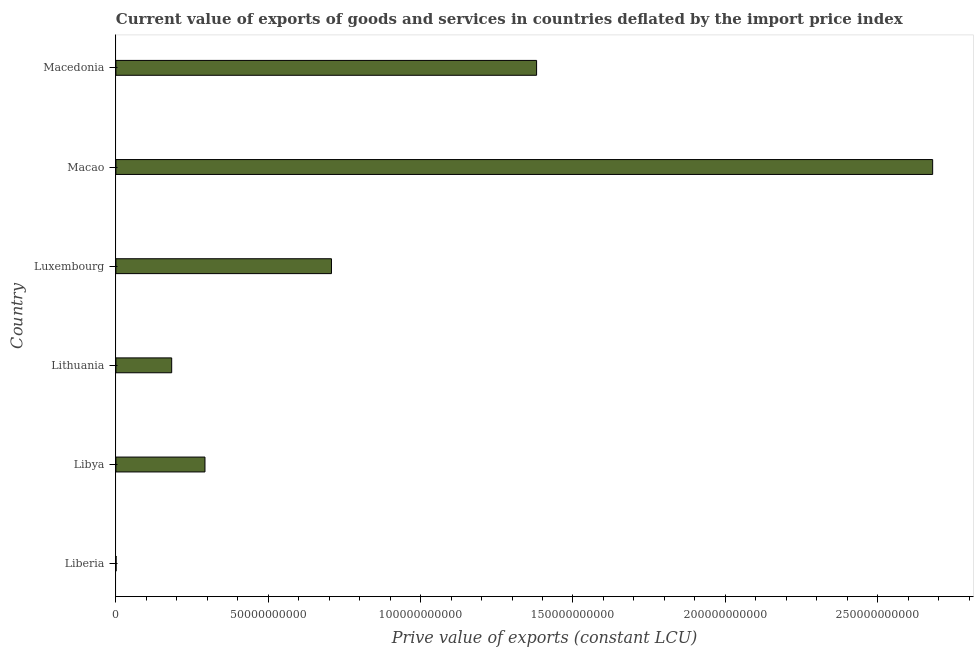Does the graph contain any zero values?
Offer a terse response. No. What is the title of the graph?
Your response must be concise. Current value of exports of goods and services in countries deflated by the import price index. What is the label or title of the X-axis?
Make the answer very short. Prive value of exports (constant LCU). What is the price value of exports in Lithuania?
Your answer should be very brief. 1.83e+1. Across all countries, what is the maximum price value of exports?
Give a very brief answer. 2.68e+11. Across all countries, what is the minimum price value of exports?
Offer a very short reply. 5.83e+07. In which country was the price value of exports maximum?
Your answer should be compact. Macao. In which country was the price value of exports minimum?
Your response must be concise. Liberia. What is the sum of the price value of exports?
Your answer should be very brief. 5.24e+11. What is the difference between the price value of exports in Libya and Macedonia?
Keep it short and to the point. -1.09e+11. What is the average price value of exports per country?
Ensure brevity in your answer.  8.74e+1. What is the median price value of exports?
Offer a very short reply. 5.00e+1. In how many countries, is the price value of exports greater than 170000000000 LCU?
Provide a short and direct response. 1. What is the ratio of the price value of exports in Libya to that in Macedonia?
Keep it short and to the point. 0.21. Is the price value of exports in Liberia less than that in Macao?
Your response must be concise. Yes. What is the difference between the highest and the second highest price value of exports?
Your answer should be very brief. 1.30e+11. What is the difference between the highest and the lowest price value of exports?
Provide a succinct answer. 2.68e+11. Are the values on the major ticks of X-axis written in scientific E-notation?
Your response must be concise. No. What is the Prive value of exports (constant LCU) in Liberia?
Ensure brevity in your answer.  5.83e+07. What is the Prive value of exports (constant LCU) in Libya?
Your answer should be very brief. 2.92e+1. What is the Prive value of exports (constant LCU) of Lithuania?
Keep it short and to the point. 1.83e+1. What is the Prive value of exports (constant LCU) of Luxembourg?
Offer a very short reply. 7.08e+1. What is the Prive value of exports (constant LCU) in Macao?
Ensure brevity in your answer.  2.68e+11. What is the Prive value of exports (constant LCU) of Macedonia?
Offer a terse response. 1.38e+11. What is the difference between the Prive value of exports (constant LCU) in Liberia and Libya?
Provide a short and direct response. -2.92e+1. What is the difference between the Prive value of exports (constant LCU) in Liberia and Lithuania?
Offer a terse response. -1.83e+1. What is the difference between the Prive value of exports (constant LCU) in Liberia and Luxembourg?
Your answer should be compact. -7.07e+1. What is the difference between the Prive value of exports (constant LCU) in Liberia and Macao?
Make the answer very short. -2.68e+11. What is the difference between the Prive value of exports (constant LCU) in Liberia and Macedonia?
Make the answer very short. -1.38e+11. What is the difference between the Prive value of exports (constant LCU) in Libya and Lithuania?
Offer a very short reply. 1.09e+1. What is the difference between the Prive value of exports (constant LCU) in Libya and Luxembourg?
Provide a succinct answer. -4.15e+1. What is the difference between the Prive value of exports (constant LCU) in Libya and Macao?
Your answer should be compact. -2.39e+11. What is the difference between the Prive value of exports (constant LCU) in Libya and Macedonia?
Offer a terse response. -1.09e+11. What is the difference between the Prive value of exports (constant LCU) in Lithuania and Luxembourg?
Offer a very short reply. -5.24e+1. What is the difference between the Prive value of exports (constant LCU) in Lithuania and Macao?
Give a very brief answer. -2.50e+11. What is the difference between the Prive value of exports (constant LCU) in Lithuania and Macedonia?
Give a very brief answer. -1.20e+11. What is the difference between the Prive value of exports (constant LCU) in Luxembourg and Macao?
Keep it short and to the point. -1.97e+11. What is the difference between the Prive value of exports (constant LCU) in Luxembourg and Macedonia?
Your response must be concise. -6.73e+1. What is the difference between the Prive value of exports (constant LCU) in Macao and Macedonia?
Your answer should be compact. 1.30e+11. What is the ratio of the Prive value of exports (constant LCU) in Liberia to that in Libya?
Give a very brief answer. 0. What is the ratio of the Prive value of exports (constant LCU) in Liberia to that in Lithuania?
Your answer should be very brief. 0. What is the ratio of the Prive value of exports (constant LCU) in Liberia to that in Macedonia?
Offer a terse response. 0. What is the ratio of the Prive value of exports (constant LCU) in Libya to that in Lithuania?
Your response must be concise. 1.6. What is the ratio of the Prive value of exports (constant LCU) in Libya to that in Luxembourg?
Your answer should be compact. 0.41. What is the ratio of the Prive value of exports (constant LCU) in Libya to that in Macao?
Provide a succinct answer. 0.11. What is the ratio of the Prive value of exports (constant LCU) in Libya to that in Macedonia?
Your answer should be compact. 0.21. What is the ratio of the Prive value of exports (constant LCU) in Lithuania to that in Luxembourg?
Your response must be concise. 0.26. What is the ratio of the Prive value of exports (constant LCU) in Lithuania to that in Macao?
Your response must be concise. 0.07. What is the ratio of the Prive value of exports (constant LCU) in Lithuania to that in Macedonia?
Offer a terse response. 0.13. What is the ratio of the Prive value of exports (constant LCU) in Luxembourg to that in Macao?
Provide a succinct answer. 0.26. What is the ratio of the Prive value of exports (constant LCU) in Luxembourg to that in Macedonia?
Make the answer very short. 0.51. What is the ratio of the Prive value of exports (constant LCU) in Macao to that in Macedonia?
Your response must be concise. 1.94. 